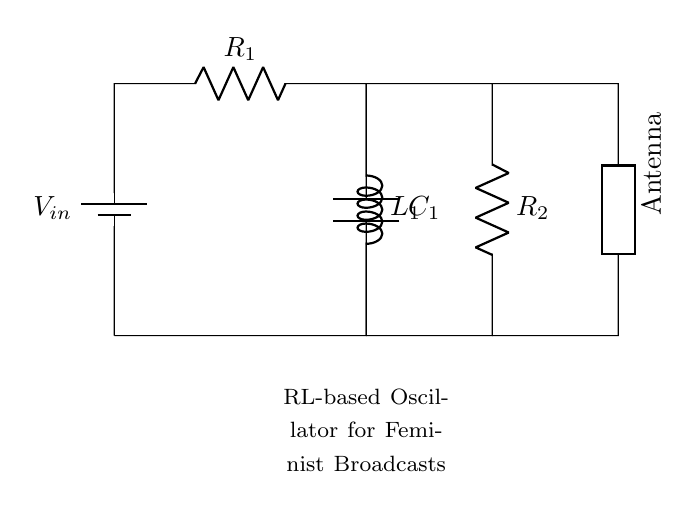What is the type of the generator in this circuit? The generator is represented by the battery symbol, indicating that it supplies voltage to the circuit.
Answer: Battery What is the total number of resistors in the circuit? There are two resistors labeled R1 and R2 in the circuit, both shown in the diagram.
Answer: 2 What component is connected in parallel with the inductor? The capacitor C1 is connected in parallel with the inductor L1, as indicated by their side-by-side setup in the circuit diagram.
Answer: Capacitor What is the function of the antenna in this circuit? The antenna serves as the output component, transmitting the modulated signal produced by the oscillator circuit.
Answer: Transmitter What is the connection type between the components R2 and the antenna? R2 connects to the antenna via a direct wire, establishing a straightforward connection for signal transmission.
Answer: Direct Explain how the RL circuit generates oscillations. The meaning of "R" for resistance and "L" for inductance indicates that the energy oscillates between the resistor and inductor when the circuit is energized. The inductor stores energy in a magnetic field while the resistor dissipates energy as heat, causing the oscillations to occur at a natural frequency determined by the values of R1, L1, and C1.
Answer: Energy oscillation What is the role of C1 in the RL-based oscillator? The capacitor C1 is a crucial part of the oscillator; it allows for energy storage and release that helps to create and sustain oscillations in combination with the inductor.
Answer: Energy storage 